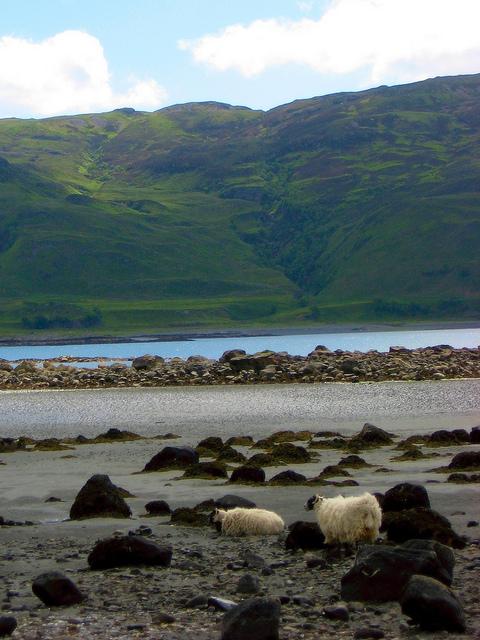How deep is the water?
Be succinct. Shallow. Is the body of water the ocean?
Answer briefly. No. Are there fewer than twenty sheep?
Write a very short answer. Yes. How many animals are in the image?
Give a very brief answer. 2. Do you think there is more than 10 sheep?
Give a very brief answer. No. What are the animals doing?
Give a very brief answer. Walking. Are there many rocks?
Be succinct. Yes. 